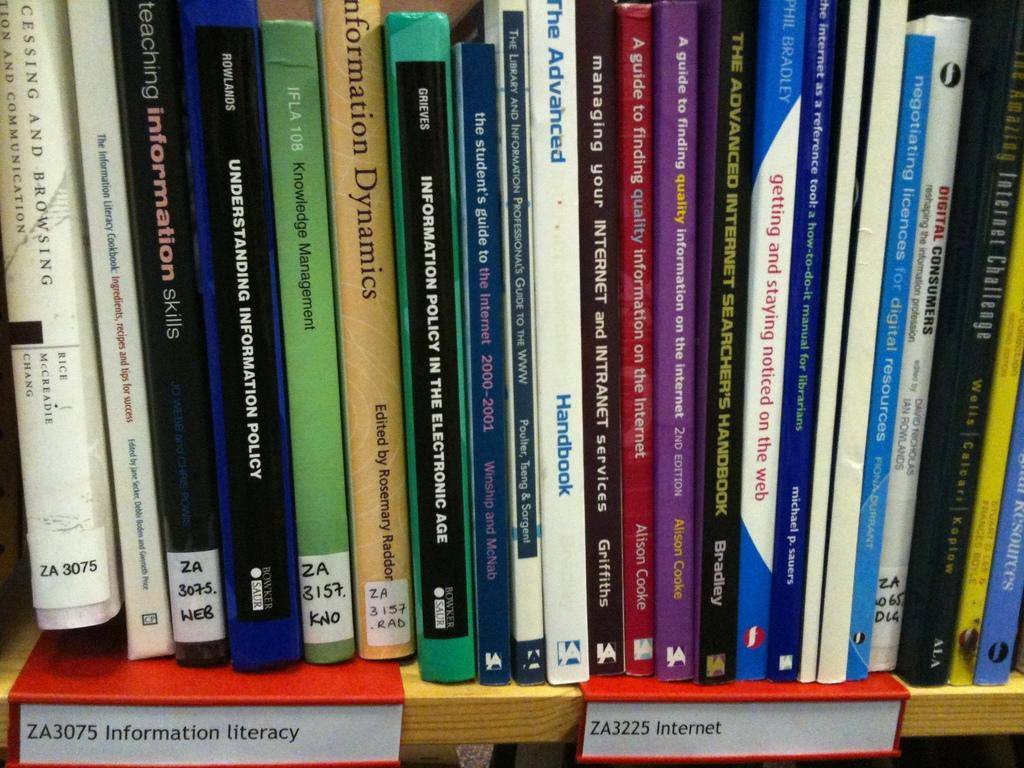<image>
Offer a succinct explanation of the picture presented. a bookshelf with information about the internet on it 